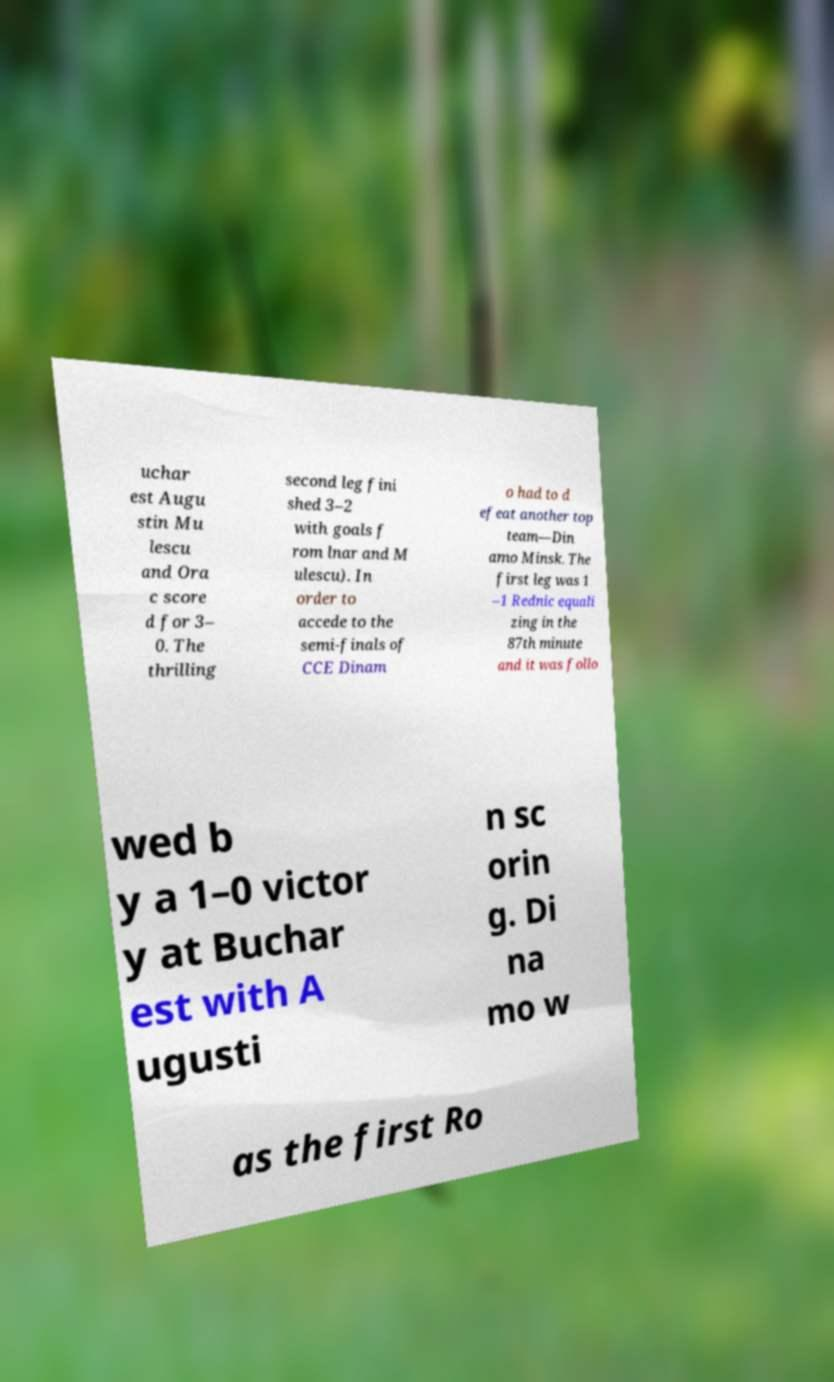Please identify and transcribe the text found in this image. uchar est Augu stin Mu lescu and Ora c score d for 3– 0. The thrilling second leg fini shed 3–2 with goals f rom lnar and M ulescu). In order to accede to the semi-finals of CCE Dinam o had to d efeat another top team—Din amo Minsk. The first leg was 1 –1 Rednic equali zing in the 87th minute and it was follo wed b y a 1–0 victor y at Buchar est with A ugusti n sc orin g. Di na mo w as the first Ro 